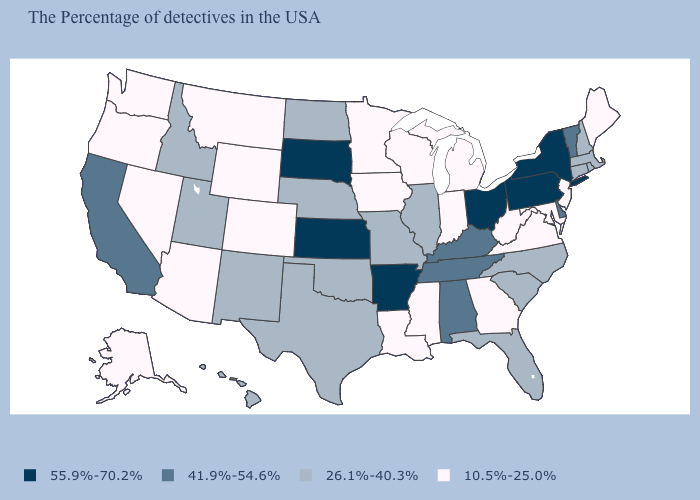Does Colorado have a lower value than Virginia?
Concise answer only. No. Does Delaware have a higher value than New Jersey?
Short answer required. Yes. What is the value of Virginia?
Quick response, please. 10.5%-25.0%. Does West Virginia have the lowest value in the USA?
Write a very short answer. Yes. What is the lowest value in states that border Maryland?
Be succinct. 10.5%-25.0%. Which states have the lowest value in the MidWest?
Answer briefly. Michigan, Indiana, Wisconsin, Minnesota, Iowa. Name the states that have a value in the range 10.5%-25.0%?
Concise answer only. Maine, New Jersey, Maryland, Virginia, West Virginia, Georgia, Michigan, Indiana, Wisconsin, Mississippi, Louisiana, Minnesota, Iowa, Wyoming, Colorado, Montana, Arizona, Nevada, Washington, Oregon, Alaska. Among the states that border Iowa , does Wisconsin have the lowest value?
Write a very short answer. Yes. What is the lowest value in states that border Ohio?
Quick response, please. 10.5%-25.0%. What is the value of Alaska?
Give a very brief answer. 10.5%-25.0%. Name the states that have a value in the range 55.9%-70.2%?
Be succinct. New York, Pennsylvania, Ohio, Arkansas, Kansas, South Dakota. Name the states that have a value in the range 10.5%-25.0%?
Concise answer only. Maine, New Jersey, Maryland, Virginia, West Virginia, Georgia, Michigan, Indiana, Wisconsin, Mississippi, Louisiana, Minnesota, Iowa, Wyoming, Colorado, Montana, Arizona, Nevada, Washington, Oregon, Alaska. Does Maryland have a higher value than North Carolina?
Answer briefly. No. Which states have the highest value in the USA?
Quick response, please. New York, Pennsylvania, Ohio, Arkansas, Kansas, South Dakota. Does Missouri have a higher value than Colorado?
Write a very short answer. Yes. 